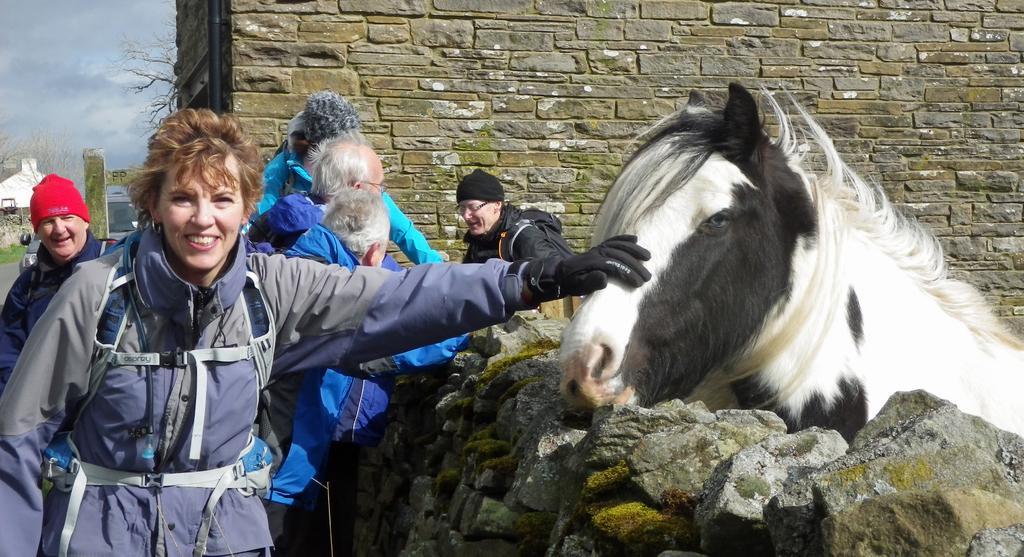Can you describe this image briefly? In this image I can see there are few persons visible in front of the stone wall on the left side and there is a horse and person and wall visible on the right side , in the top left there is the sky and tree, building visible 